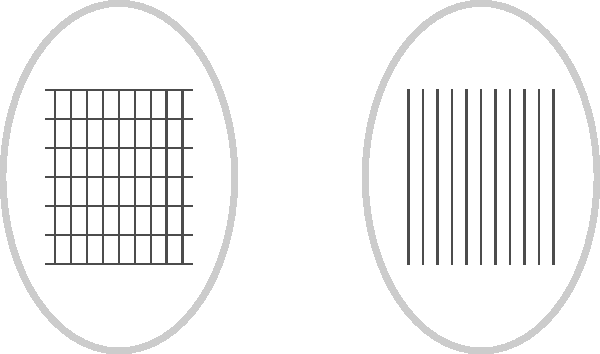As a keen amateur tennis player, you're likely familiar with various racket string patterns. The image above shows three common string patterns used in tennis rackets. Which of these patterns (A, B, or C) represents the popular 16x19 string configuration? To determine which pattern represents the 16x19 string configuration, let's analyze each racket:

1. Racket A:
   - Vertical strings: 9 visible (16 total, as some are hidden at the edges)
   - Horizontal strings: 10 visible (19 total, counting the spaces)
   This matches the 16x19 configuration.

2. Racket B:
   - Vertical strings: 11 visible (18 total)
   - Horizontal strings: 11 visible (20 total, counting the spaces)
   This represents an 18x20 configuration.

3. Racket C:
   - Vertical strings: 9 visible (16 total, as some are hidden at the edges)
   - Horizontal strings: 8 visible (15 total, counting the spaces)
   This represents a 16x15 configuration.

Therefore, Racket A represents the 16x19 string configuration.
Answer: A 